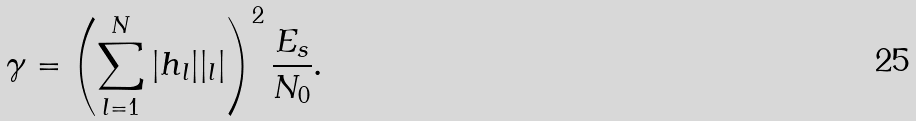<formula> <loc_0><loc_0><loc_500><loc_500>\gamma = \left ( \sum _ { l = 1 } ^ { N } | h _ { l } | | _ { l } | \right ) ^ { 2 } \frac { E _ { s } } { N _ { 0 } } .</formula> 